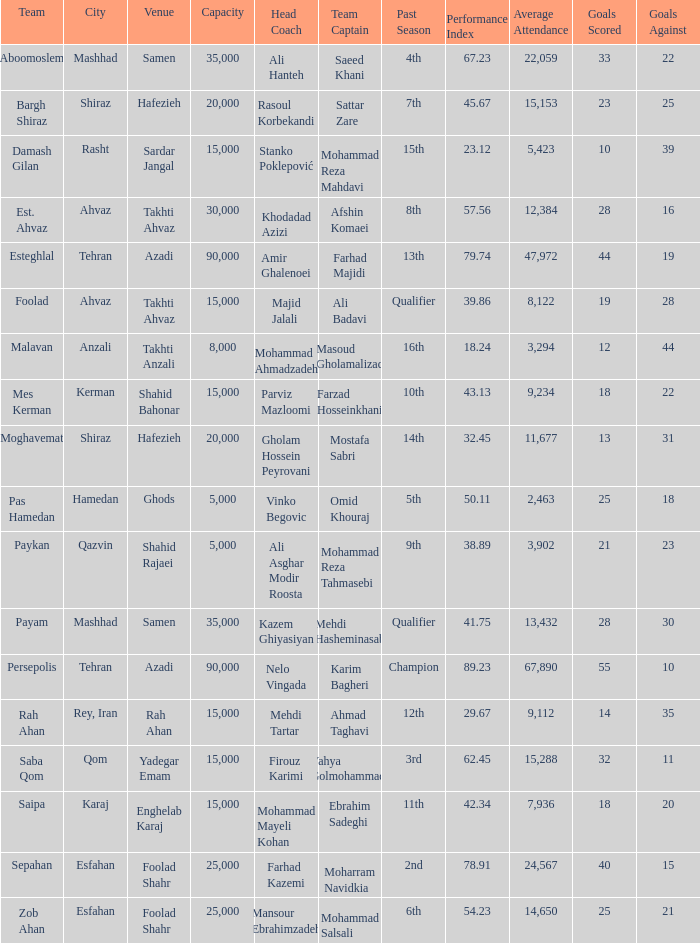What is the Capacity of the Venue of Head Coach Farhad Kazemi? 25000.0. 